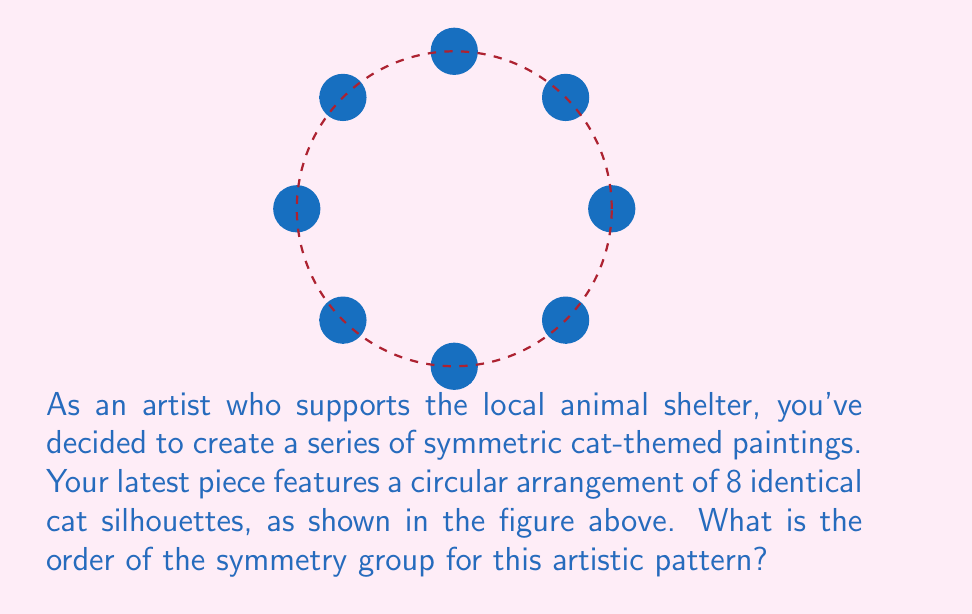Help me with this question. To determine the order of the symmetry group for this artistic pattern, we need to count all the symmetry operations that leave the pattern unchanged. Let's break this down step-by-step:

1) Rotational symmetries:
   The pattern has 8 identical cat silhouettes arranged in a circle. This means we have rotational symmetry of order 8. The rotations are:
   $$\{0°, 45°, 90°, 135°, 180°, 225°, 270°, 315°\}$$

2) Reflection symmetries:
   There are 8 lines of reflection:
   - 4 passing through the cats (vertical, horizontal, and two diagonal lines)
   - 4 passing between the cats (bisecting the angles between the main diagonals)

3) Identity transformation:
   The identity transformation (doing nothing) is always a symmetry.

To calculate the total number of symmetries, we add these together:
$$\text{Total symmetries} = \text{Rotations} + \text{Reflections} + \text{Identity}$$
$$\text{Total symmetries} = 8 + 8 + 1 = 17$$

The order of a group is the number of elements in the group. Therefore, the order of the symmetry group for this pattern is 17.

In group theory, this symmetry group is known as the dihedral group $D_8$, which always has order $2n$ where $n$ is the number of vertices (or in this case, cats). The formula $2n + 1$ gives us $2(8) + 1 = 17$.
Answer: 17 